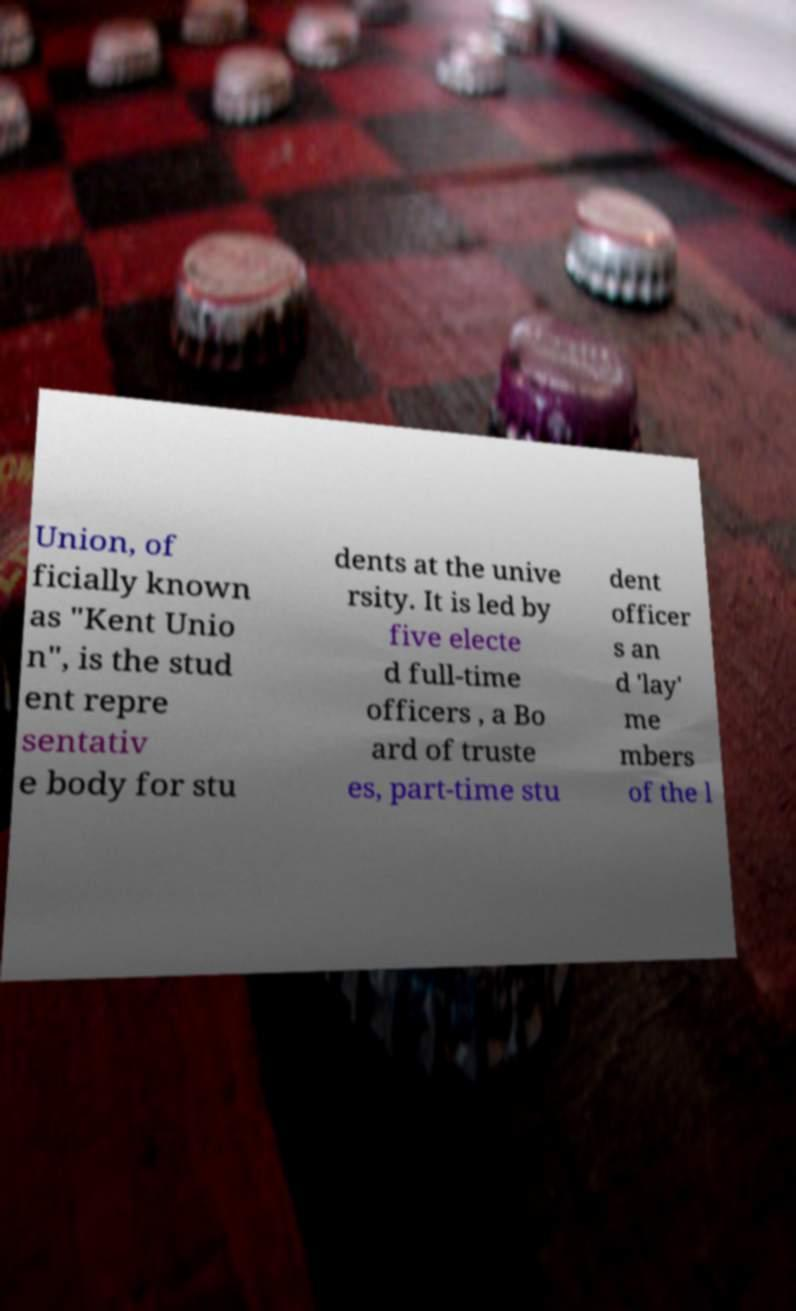What messages or text are displayed in this image? I need them in a readable, typed format. Union, of ficially known as "Kent Unio n", is the stud ent repre sentativ e body for stu dents at the unive rsity. It is led by five electe d full-time officers , a Bo ard of truste es, part-time stu dent officer s an d 'lay' me mbers of the l 